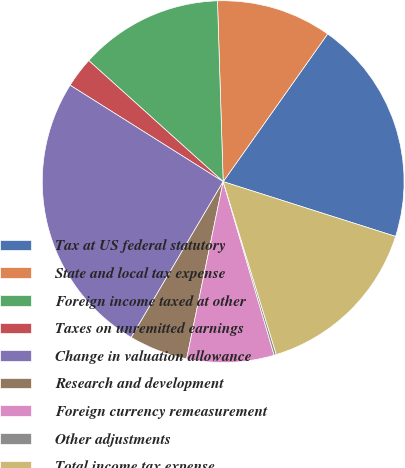<chart> <loc_0><loc_0><loc_500><loc_500><pie_chart><fcel>Tax at US federal statutory<fcel>State and local tax expense<fcel>Foreign income taxed at other<fcel>Taxes on unremitted earnings<fcel>Change in valuation allowance<fcel>Research and development<fcel>Foreign currency remeasurement<fcel>Other adjustments<fcel>Total income tax expense<nl><fcel>20.1%<fcel>10.3%<fcel>12.83%<fcel>2.72%<fcel>25.46%<fcel>5.25%<fcel>7.78%<fcel>0.2%<fcel>15.36%<nl></chart> 